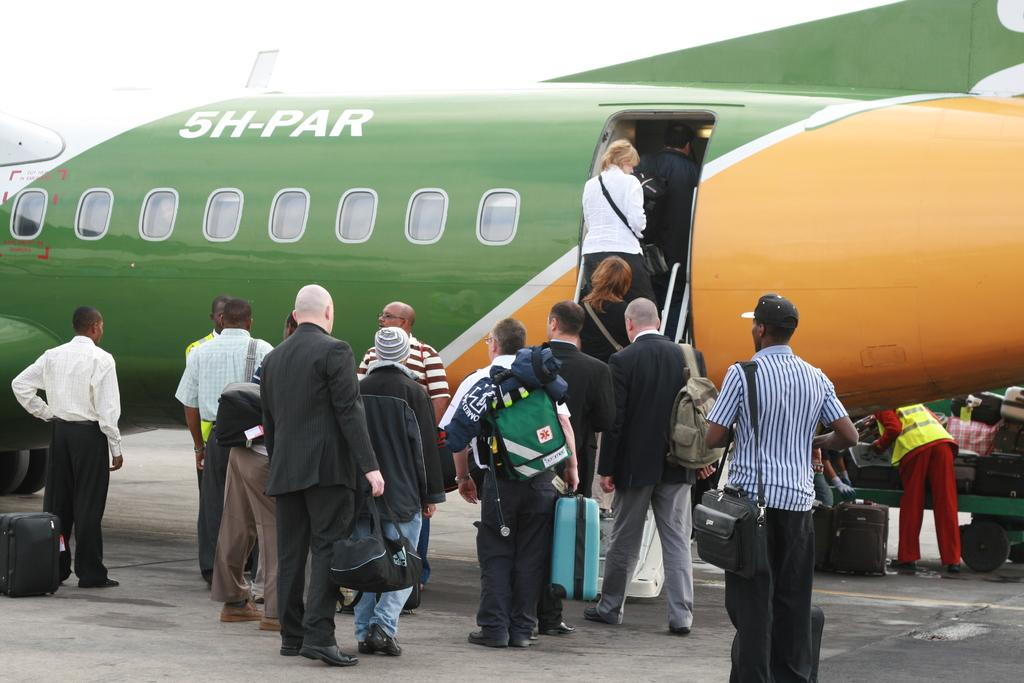What is happening with the group of people in the image? The people in the image are walking and holding bags. What else can be seen in the image besides the group of people? There is an airplane in the image. Can you describe the airplane in the image? The airplane is in green and orange colors and has windows. What other object can be seen in the image that is green in color? There is a green color trolley in the image. How many pigs are sitting inside the airplane in the image? There are no pigs present in the image; it features a group of people walking and holding bags, as well as an airplane. Can you tell me where the drawer is located in the image? There is no drawer present in the image. 